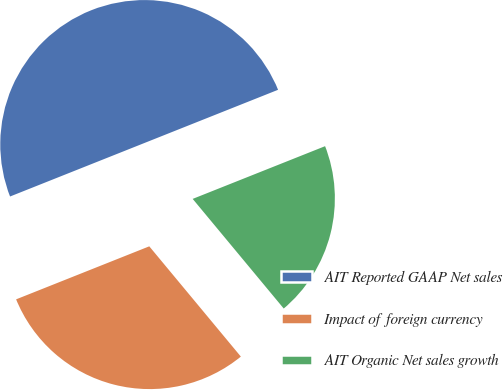Convert chart to OTSL. <chart><loc_0><loc_0><loc_500><loc_500><pie_chart><fcel>AIT Reported GAAP Net sales<fcel>Impact of foreign currency<fcel>AIT Organic Net sales growth<nl><fcel>50.0%<fcel>30.0%<fcel>20.0%<nl></chart> 